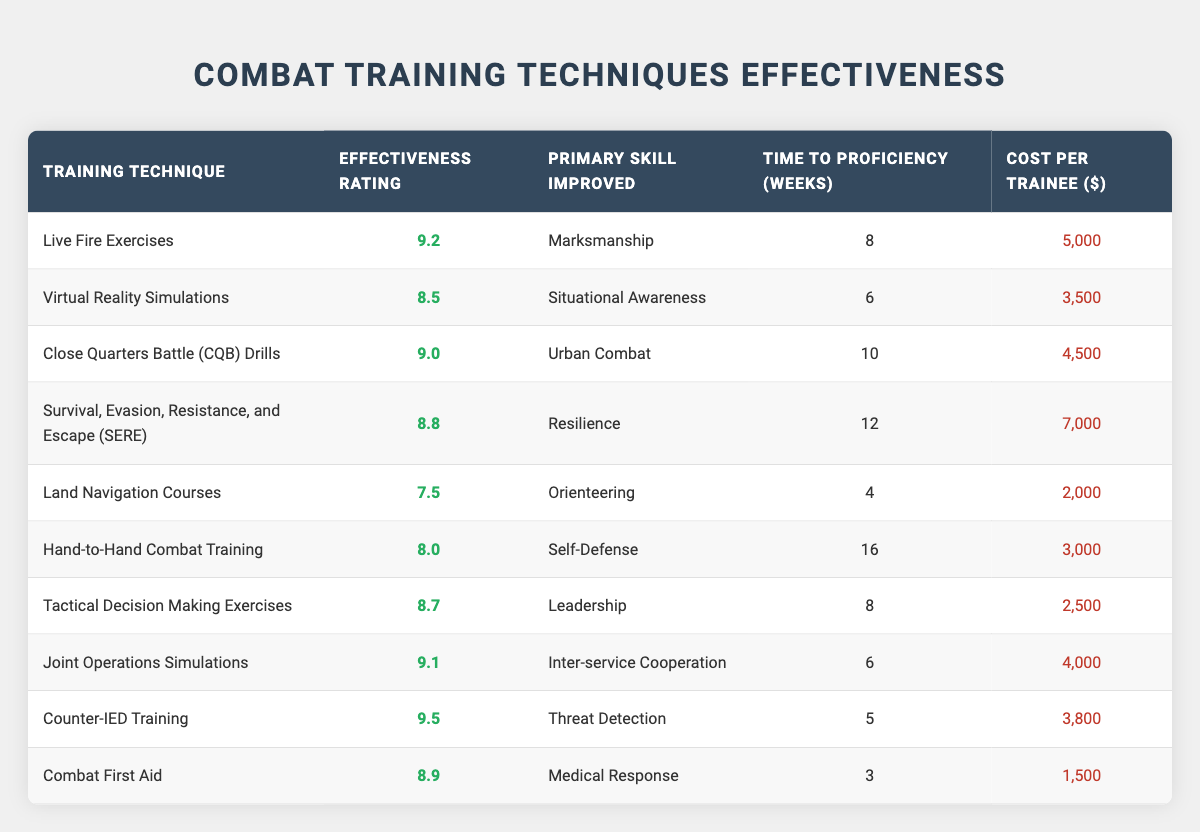What is the effectiveness rating of Live Fire Exercises? The effectiveness rating for Live Fire Exercises is displayed in the second column of the table. It shows a value of 9.2.
Answer: 9.2 Which training technique has the lowest effectiveness rating? The lowest effectiveness rating is found by comparing values in the second column. Land Navigation Courses has the lowest effectiveness rating of 7.5.
Answer: Land Navigation Courses What is the cost per trainee for Combat First Aid? The cost per trainee for Combat First Aid is listed in the fifth column of the table, showing a value of 1500.
Answer: 1500 What is the average time to proficiency for all training techniques? To find the average, sum the values of the time to proficiency for each technique (8 + 6 + 10 + 12 + 4 + 16 + 8 + 6 + 5 + 3 = 78) and divide by the number of techniques (10). Therefore, the average time to proficiency is 78 / 10 = 7.8 weeks.
Answer: 7.8 weeks Is the effectiveness rating of Counter-IED Training greater than the effectiveness rating of Close Quarters Battle Drills? Counter-IED Training has an effectiveness rating of 9.5 while Close Quarters Battle Drills has a rating of 9.0. Since 9.5 is greater than 9.0, the statement is true.
Answer: Yes Which training technique requires the most weeks to achieve proficiency? The longest time to proficiency can be found by looking at the fourth column. Hand-to-Hand Combat Training takes 16 weeks, which is the highest value in that column.
Answer: Hand-to-Hand Combat Training How much more does it cost to train a trainee in SERE compared to Land Navigation Courses? First, find the cost per trainee for SERE, which is 7000, and for Land Navigation Courses, which is 2000. Then calculate the difference: 7000 - 2000 = 5000.
Answer: 5000 Are there any training techniques that improve self-defense skills with an effectiveness rating above 8.0? Hand-to-Hand Combat Training improves self-defense skills and has an effectiveness rating of 8.0. Therefore, no training techniques with self-defense improvement exceed that rating.
Answer: No What is the total effectiveness rating of the four training techniques that improve medical skills (if any)? The only training technique that improves medical skills is Combat First Aid with an effectiveness rating of 8.9. Therefore, the total effectiveness rating is simply 8.9.
Answer: 8.9 